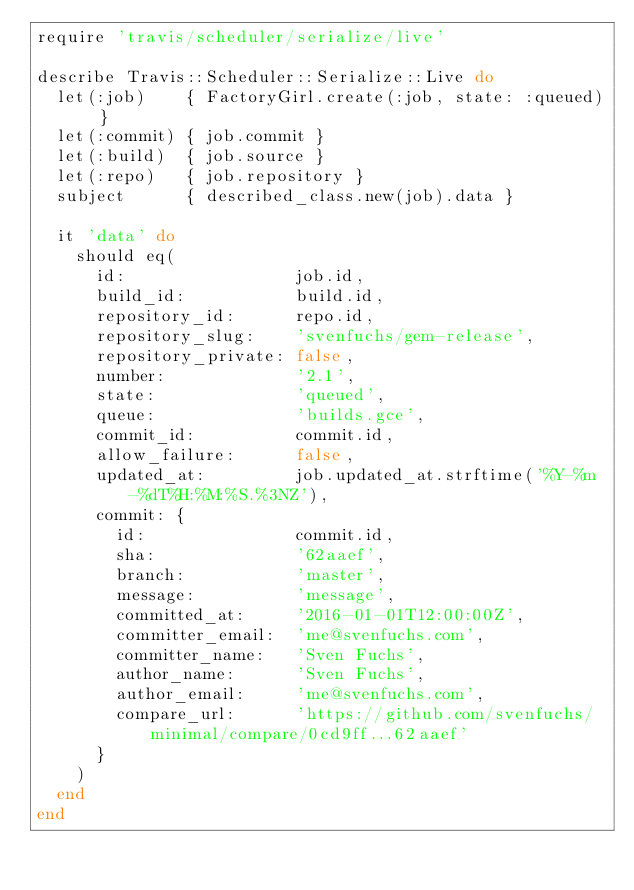<code> <loc_0><loc_0><loc_500><loc_500><_Ruby_>require 'travis/scheduler/serialize/live'

describe Travis::Scheduler::Serialize::Live do
  let(:job)    { FactoryGirl.create(:job, state: :queued) }
  let(:commit) { job.commit }
  let(:build)  { job.source }
  let(:repo)   { job.repository }
  subject      { described_class.new(job).data }

  it 'data' do
    should eq(
      id:                 job.id,
      build_id:           build.id,
      repository_id:      repo.id,
      repository_slug:    'svenfuchs/gem-release',
      repository_private: false,
      number:             '2.1',
      state:              'queued',
      queue:              'builds.gce',
      commit_id:          commit.id,
      allow_failure:      false,
      updated_at:         job.updated_at.strftime('%Y-%m-%dT%H:%M:%S.%3NZ'),
      commit: {
        id:               commit.id,
        sha:              '62aaef',
        branch:           'master',
        message:          'message',
        committed_at:     '2016-01-01T12:00:00Z',
        committer_email:  'me@svenfuchs.com',
        committer_name:   'Sven Fuchs',
        author_name:      'Sven Fuchs',
        author_email:     'me@svenfuchs.com',
        compare_url:      'https://github.com/svenfuchs/minimal/compare/0cd9ff...62aaef'
      }
    )
  end
end
</code> 